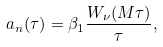<formula> <loc_0><loc_0><loc_500><loc_500>a _ { n } ( \tau ) = \beta _ { 1 } \frac { W _ { \nu } ( M \tau ) } { \tau } ,</formula> 